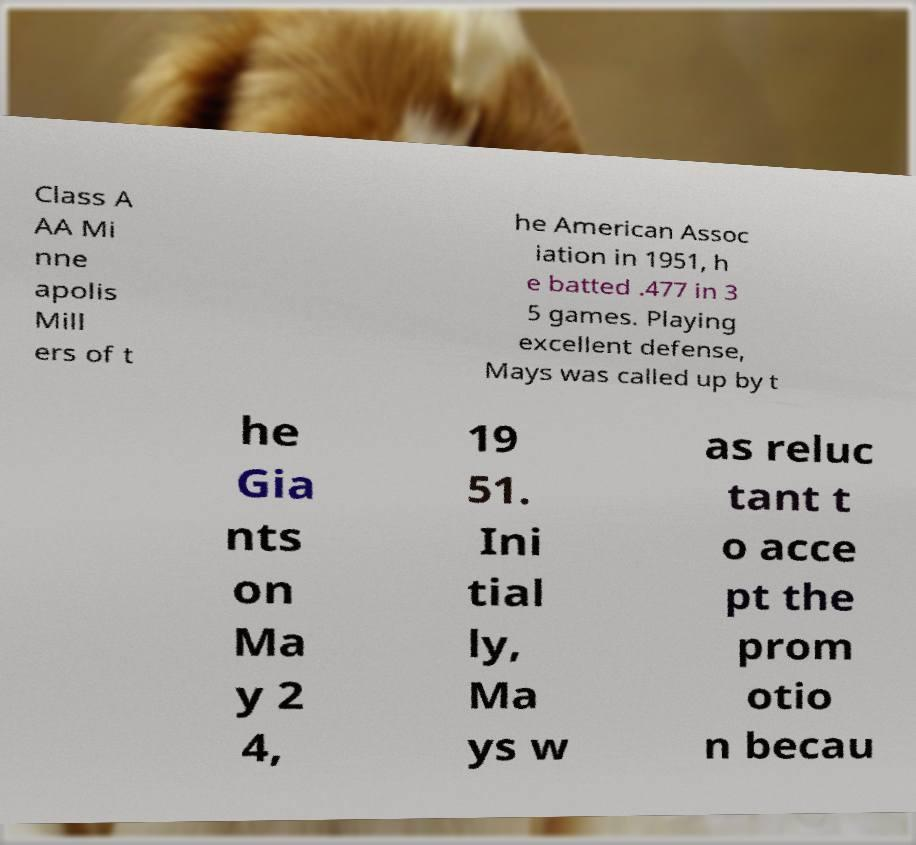I need the written content from this picture converted into text. Can you do that? Class A AA Mi nne apolis Mill ers of t he American Assoc iation in 1951, h e batted .477 in 3 5 games. Playing excellent defense, Mays was called up by t he Gia nts on Ma y 2 4, 19 51. Ini tial ly, Ma ys w as reluc tant t o acce pt the prom otio n becau 